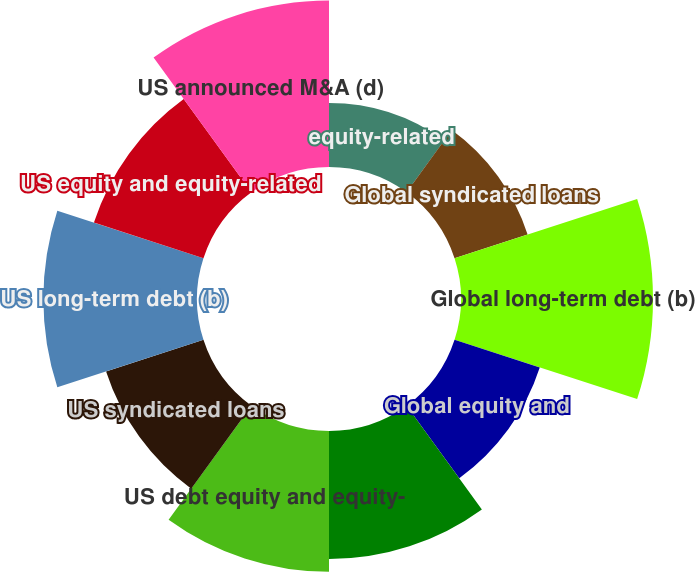Convert chart. <chart><loc_0><loc_0><loc_500><loc_500><pie_chart><fcel>equity-related<fcel>Global syndicated loans<fcel>Global long-term debt (b)<fcel>Global equity and<fcel>Global announced M&A (d)<fcel>US debt equity and equity-<fcel>US syndicated loans<fcel>US long-term debt (b)<fcel>US equity and equity-related<fcel>US announced M&A (d)<nl><fcel>5.21%<fcel>6.25%<fcel>15.62%<fcel>7.29%<fcel>10.42%<fcel>11.46%<fcel>8.33%<fcel>12.5%<fcel>9.37%<fcel>13.54%<nl></chart> 